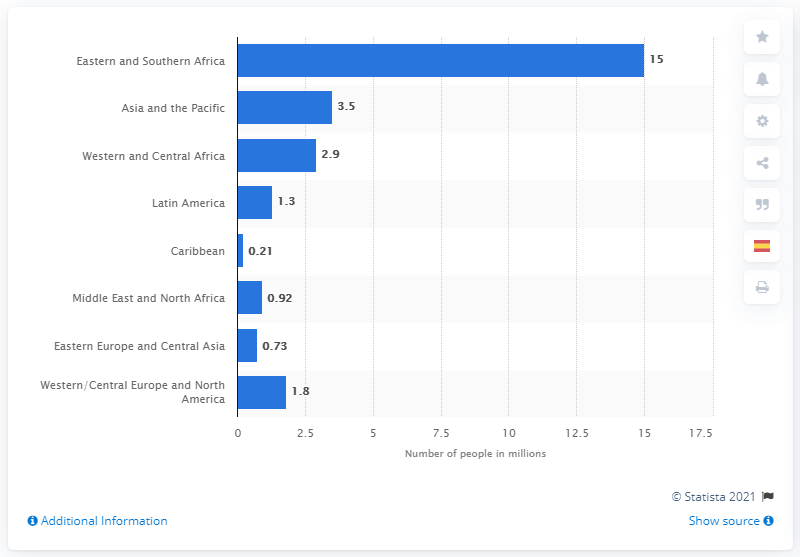Point out several critical features in this image. In 2019, an estimated 3.5 million people in the Asia-Pacific region were receiving antiretroviral therapy (ART) for HIV treatment. 